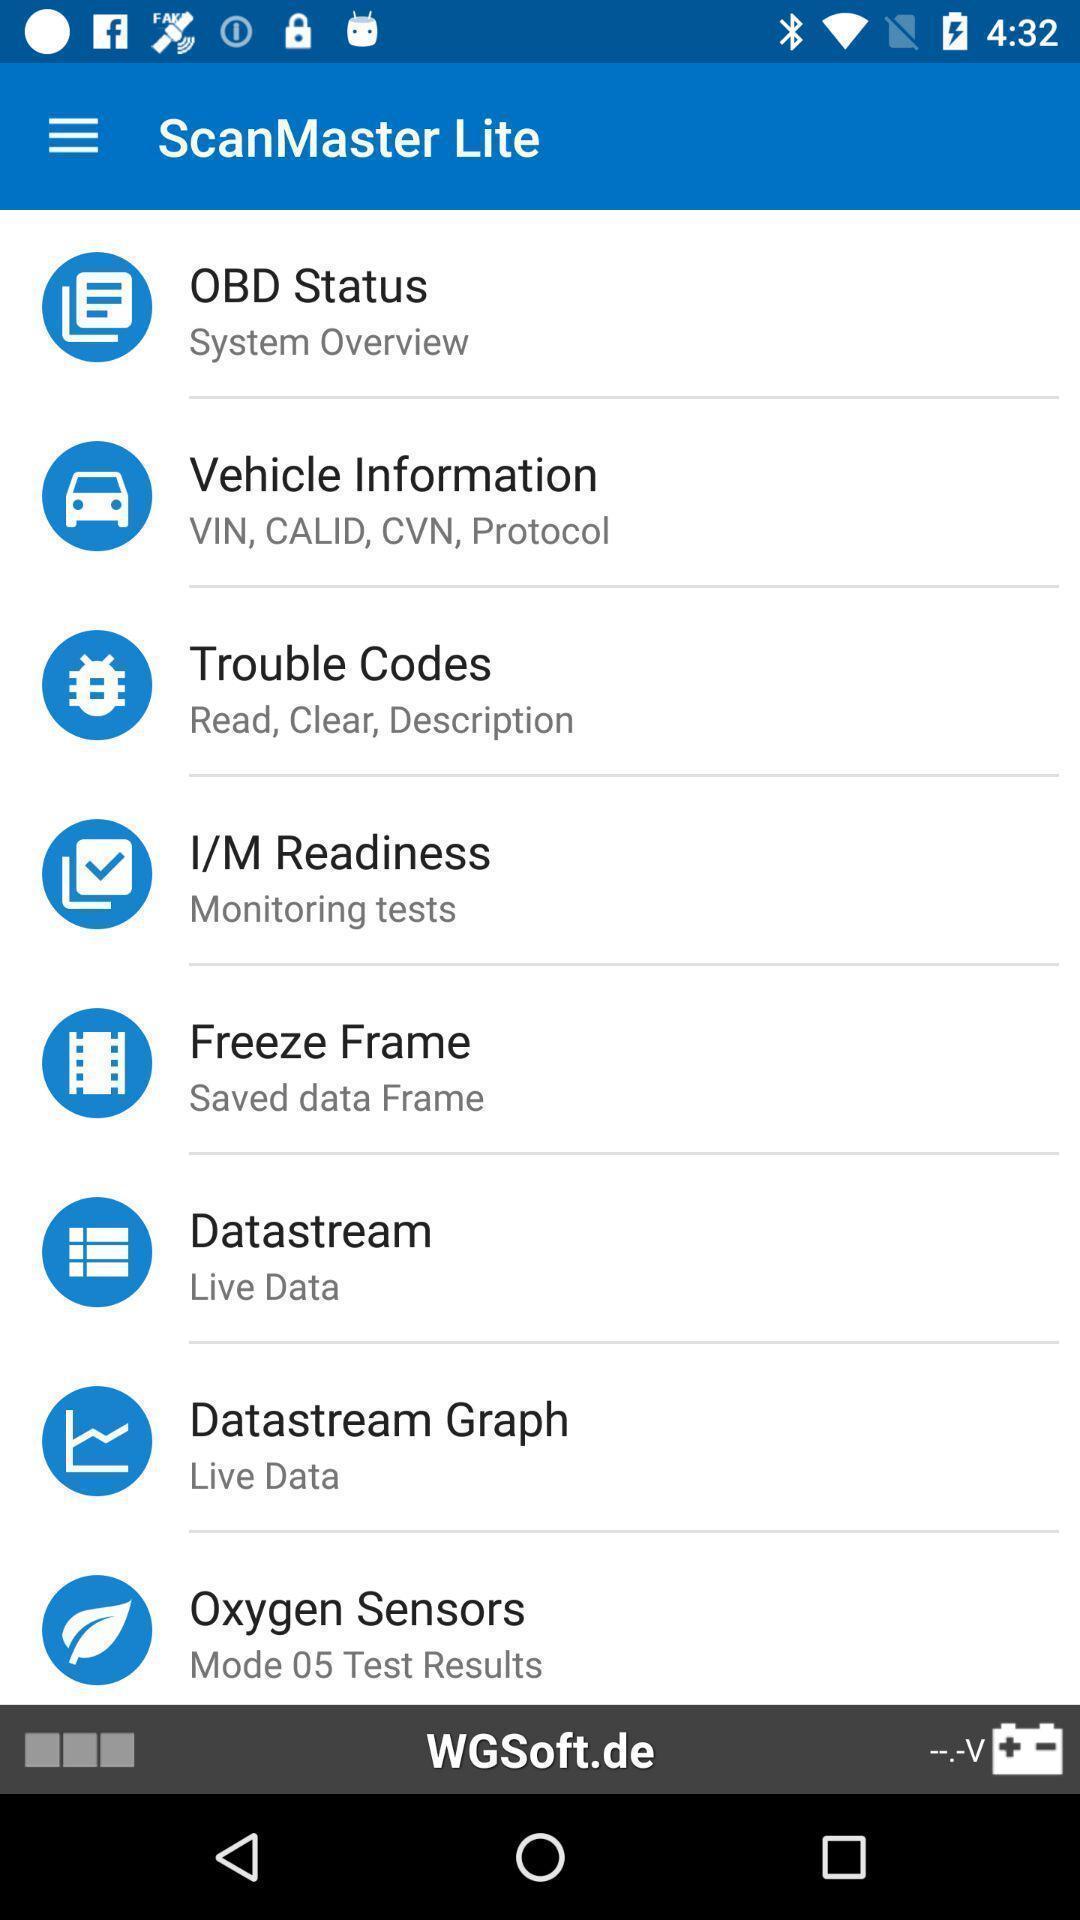Describe the key features of this screenshot. Screen displaying multiple options in a scanning application. 